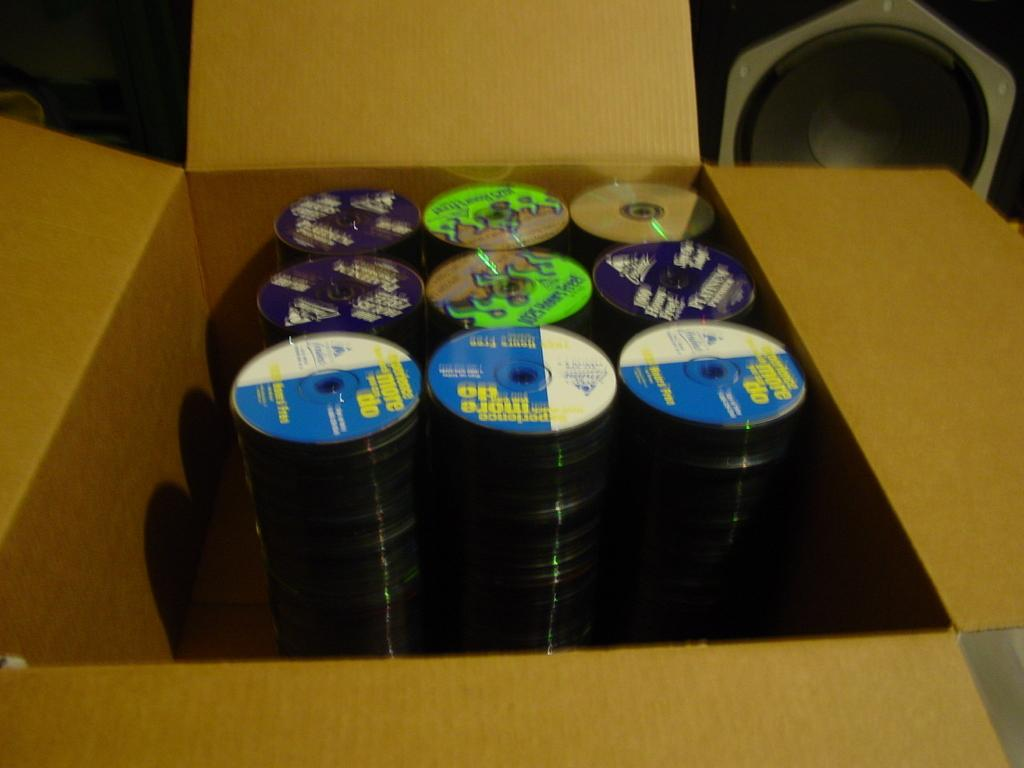What type of objects are visible in the image? There are CDs in the image. How are the CDs arranged or stored in the image? The CDs are placed in a box. What type of sail can be seen on the CDs in the image? There is no sail present on the CDs in the image; they are simply stored in a box. 